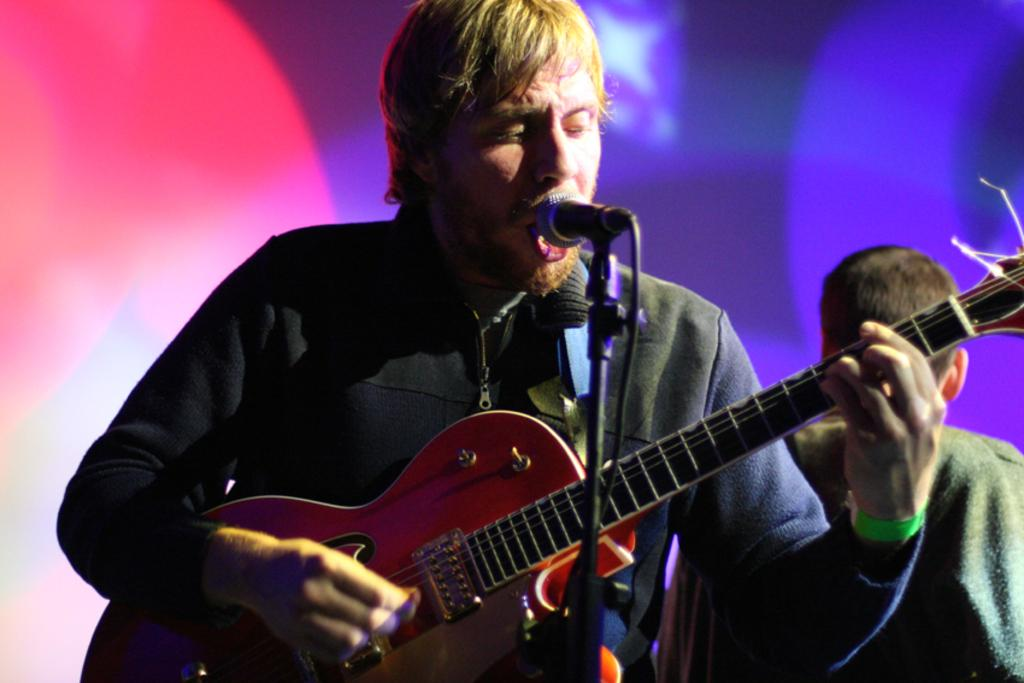What is the man in the image doing? The man is singing. What instrument is the man holding? The man holds a guitar. What device is the man using to amplify his voice? The man has a microphone in front of him. What color is the sweatshirt the man is wearing? The man is wearing a black sweatshirt. Can you describe the presence of another person in the image? There is another man behind him. How would you describe the lighting in the image? There are different shades of light in the image. What position does the cannon hold in the image? There is no cannon present in the image. Can you tell me the type of berry the man is holding in the image? The man is not holding any berries in the image; he is holding a guitar. 